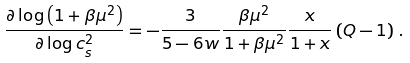<formula> <loc_0><loc_0><loc_500><loc_500>\frac { \partial \log \left ( 1 + \beta \mu ^ { 2 } \right ) } { \partial \log c _ { s } ^ { 2 } } = - \frac { 3 } { 5 - 6 w } \frac { \beta \mu ^ { 2 } } { 1 + \beta \mu ^ { 2 } } \frac { x } { 1 + x } \left ( Q - 1 \right ) \, .</formula> 